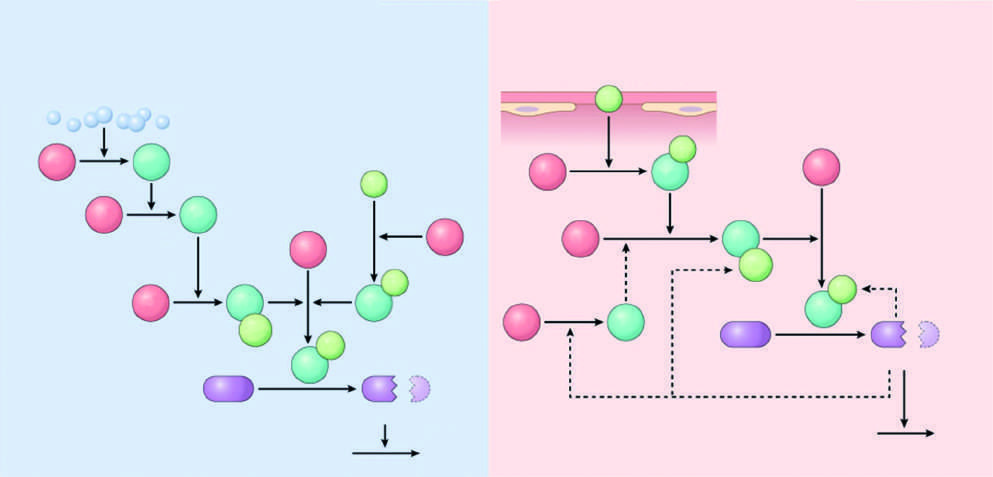do the necrotic cells correspond to cofactors?
Answer the question using a single word or phrase. No 